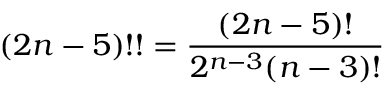<formula> <loc_0><loc_0><loc_500><loc_500>( 2 n - 5 ) ! ! = { \frac { ( 2 n - 5 ) ! } { 2 ^ { n - 3 } ( n - 3 ) ! } }</formula> 